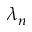<formula> <loc_0><loc_0><loc_500><loc_500>\lambda _ { n }</formula> 